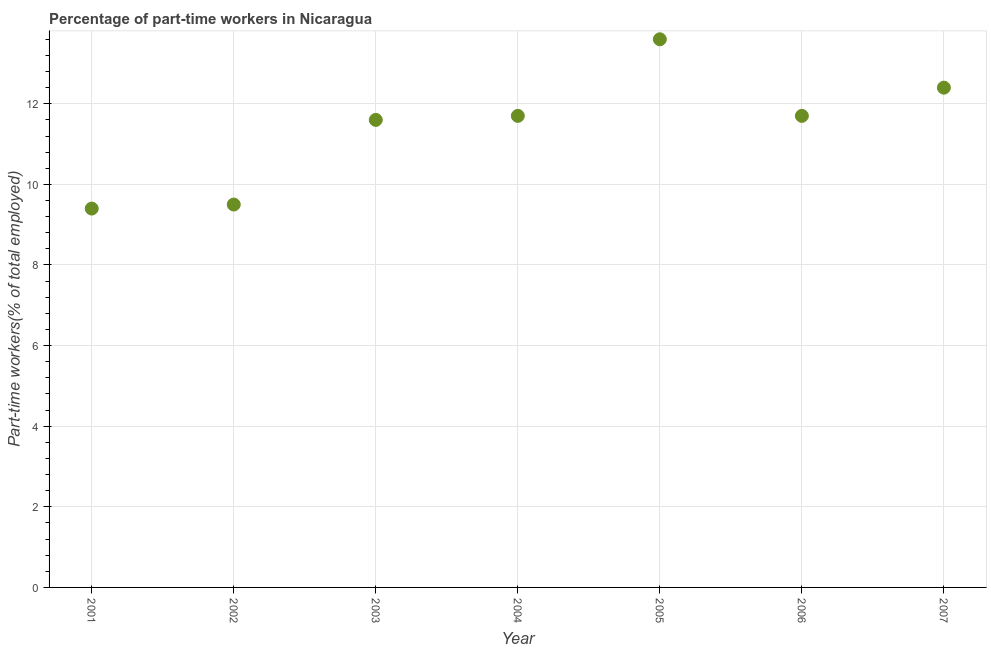What is the percentage of part-time workers in 2003?
Offer a very short reply. 11.6. Across all years, what is the maximum percentage of part-time workers?
Your response must be concise. 13.6. Across all years, what is the minimum percentage of part-time workers?
Provide a short and direct response. 9.4. In which year was the percentage of part-time workers maximum?
Provide a succinct answer. 2005. In which year was the percentage of part-time workers minimum?
Make the answer very short. 2001. What is the sum of the percentage of part-time workers?
Your answer should be very brief. 79.9. What is the difference between the percentage of part-time workers in 2004 and 2007?
Your answer should be compact. -0.7. What is the average percentage of part-time workers per year?
Your response must be concise. 11.41. What is the median percentage of part-time workers?
Keep it short and to the point. 11.7. Do a majority of the years between 2003 and 2002 (inclusive) have percentage of part-time workers greater than 6.4 %?
Ensure brevity in your answer.  No. What is the ratio of the percentage of part-time workers in 2001 to that in 2004?
Give a very brief answer. 0.8. Is the percentage of part-time workers in 2001 less than that in 2005?
Provide a short and direct response. Yes. What is the difference between the highest and the second highest percentage of part-time workers?
Keep it short and to the point. 1.2. Is the sum of the percentage of part-time workers in 2002 and 2003 greater than the maximum percentage of part-time workers across all years?
Ensure brevity in your answer.  Yes. What is the difference between the highest and the lowest percentage of part-time workers?
Your response must be concise. 4.2. How many dotlines are there?
Provide a short and direct response. 1. What is the difference between two consecutive major ticks on the Y-axis?
Offer a terse response. 2. Does the graph contain grids?
Offer a terse response. Yes. What is the title of the graph?
Offer a very short reply. Percentage of part-time workers in Nicaragua. What is the label or title of the Y-axis?
Keep it short and to the point. Part-time workers(% of total employed). What is the Part-time workers(% of total employed) in 2001?
Offer a very short reply. 9.4. What is the Part-time workers(% of total employed) in 2003?
Give a very brief answer. 11.6. What is the Part-time workers(% of total employed) in 2004?
Your answer should be compact. 11.7. What is the Part-time workers(% of total employed) in 2005?
Make the answer very short. 13.6. What is the Part-time workers(% of total employed) in 2006?
Your response must be concise. 11.7. What is the Part-time workers(% of total employed) in 2007?
Your answer should be very brief. 12.4. What is the difference between the Part-time workers(% of total employed) in 2001 and 2007?
Make the answer very short. -3. What is the difference between the Part-time workers(% of total employed) in 2002 and 2005?
Provide a succinct answer. -4.1. What is the difference between the Part-time workers(% of total employed) in 2002 and 2006?
Make the answer very short. -2.2. What is the difference between the Part-time workers(% of total employed) in 2003 and 2005?
Provide a succinct answer. -2. What is the difference between the Part-time workers(% of total employed) in 2003 and 2006?
Provide a succinct answer. -0.1. What is the difference between the Part-time workers(% of total employed) in 2004 and 2006?
Ensure brevity in your answer.  0. What is the difference between the Part-time workers(% of total employed) in 2004 and 2007?
Offer a very short reply. -0.7. What is the ratio of the Part-time workers(% of total employed) in 2001 to that in 2002?
Provide a succinct answer. 0.99. What is the ratio of the Part-time workers(% of total employed) in 2001 to that in 2003?
Offer a terse response. 0.81. What is the ratio of the Part-time workers(% of total employed) in 2001 to that in 2004?
Make the answer very short. 0.8. What is the ratio of the Part-time workers(% of total employed) in 2001 to that in 2005?
Keep it short and to the point. 0.69. What is the ratio of the Part-time workers(% of total employed) in 2001 to that in 2006?
Ensure brevity in your answer.  0.8. What is the ratio of the Part-time workers(% of total employed) in 2001 to that in 2007?
Make the answer very short. 0.76. What is the ratio of the Part-time workers(% of total employed) in 2002 to that in 2003?
Make the answer very short. 0.82. What is the ratio of the Part-time workers(% of total employed) in 2002 to that in 2004?
Offer a very short reply. 0.81. What is the ratio of the Part-time workers(% of total employed) in 2002 to that in 2005?
Ensure brevity in your answer.  0.7. What is the ratio of the Part-time workers(% of total employed) in 2002 to that in 2006?
Give a very brief answer. 0.81. What is the ratio of the Part-time workers(% of total employed) in 2002 to that in 2007?
Provide a succinct answer. 0.77. What is the ratio of the Part-time workers(% of total employed) in 2003 to that in 2005?
Your answer should be very brief. 0.85. What is the ratio of the Part-time workers(% of total employed) in 2003 to that in 2007?
Ensure brevity in your answer.  0.94. What is the ratio of the Part-time workers(% of total employed) in 2004 to that in 2005?
Make the answer very short. 0.86. What is the ratio of the Part-time workers(% of total employed) in 2004 to that in 2007?
Offer a very short reply. 0.94. What is the ratio of the Part-time workers(% of total employed) in 2005 to that in 2006?
Provide a short and direct response. 1.16. What is the ratio of the Part-time workers(% of total employed) in 2005 to that in 2007?
Your answer should be compact. 1.1. What is the ratio of the Part-time workers(% of total employed) in 2006 to that in 2007?
Keep it short and to the point. 0.94. 